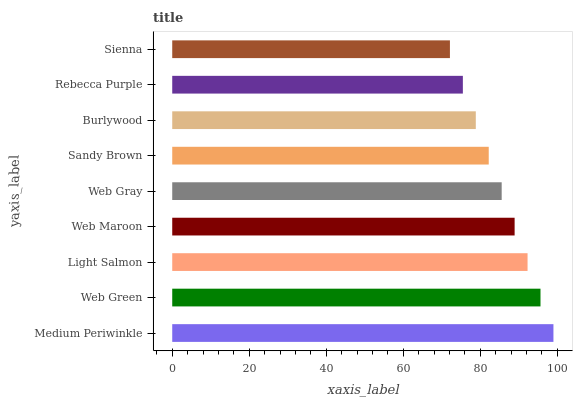Is Sienna the minimum?
Answer yes or no. Yes. Is Medium Periwinkle the maximum?
Answer yes or no. Yes. Is Web Green the minimum?
Answer yes or no. No. Is Web Green the maximum?
Answer yes or no. No. Is Medium Periwinkle greater than Web Green?
Answer yes or no. Yes. Is Web Green less than Medium Periwinkle?
Answer yes or no. Yes. Is Web Green greater than Medium Periwinkle?
Answer yes or no. No. Is Medium Periwinkle less than Web Green?
Answer yes or no. No. Is Web Gray the high median?
Answer yes or no. Yes. Is Web Gray the low median?
Answer yes or no. Yes. Is Rebecca Purple the high median?
Answer yes or no. No. Is Web Green the low median?
Answer yes or no. No. 